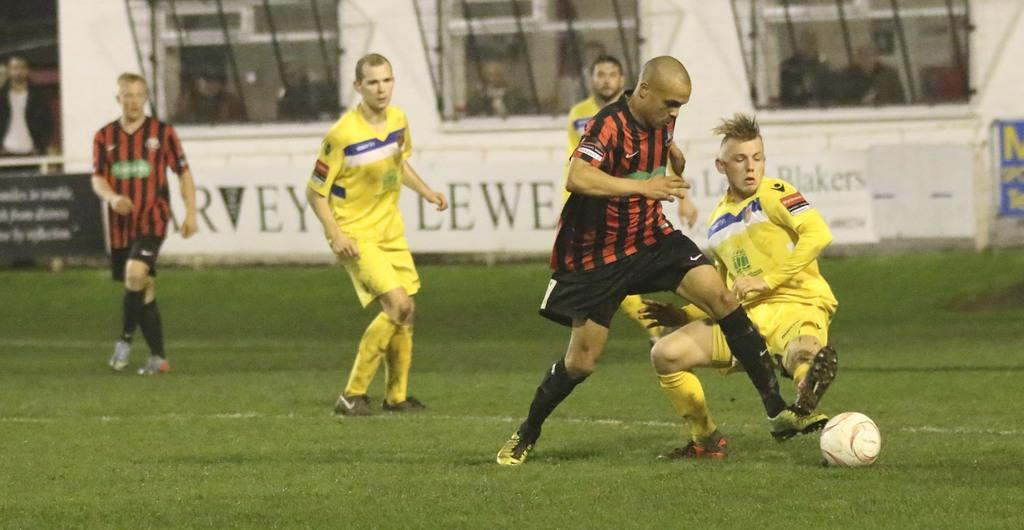<image>
Give a short and clear explanation of the subsequent image. Soccer players play a game on a field with a banner with the text Blakers. 